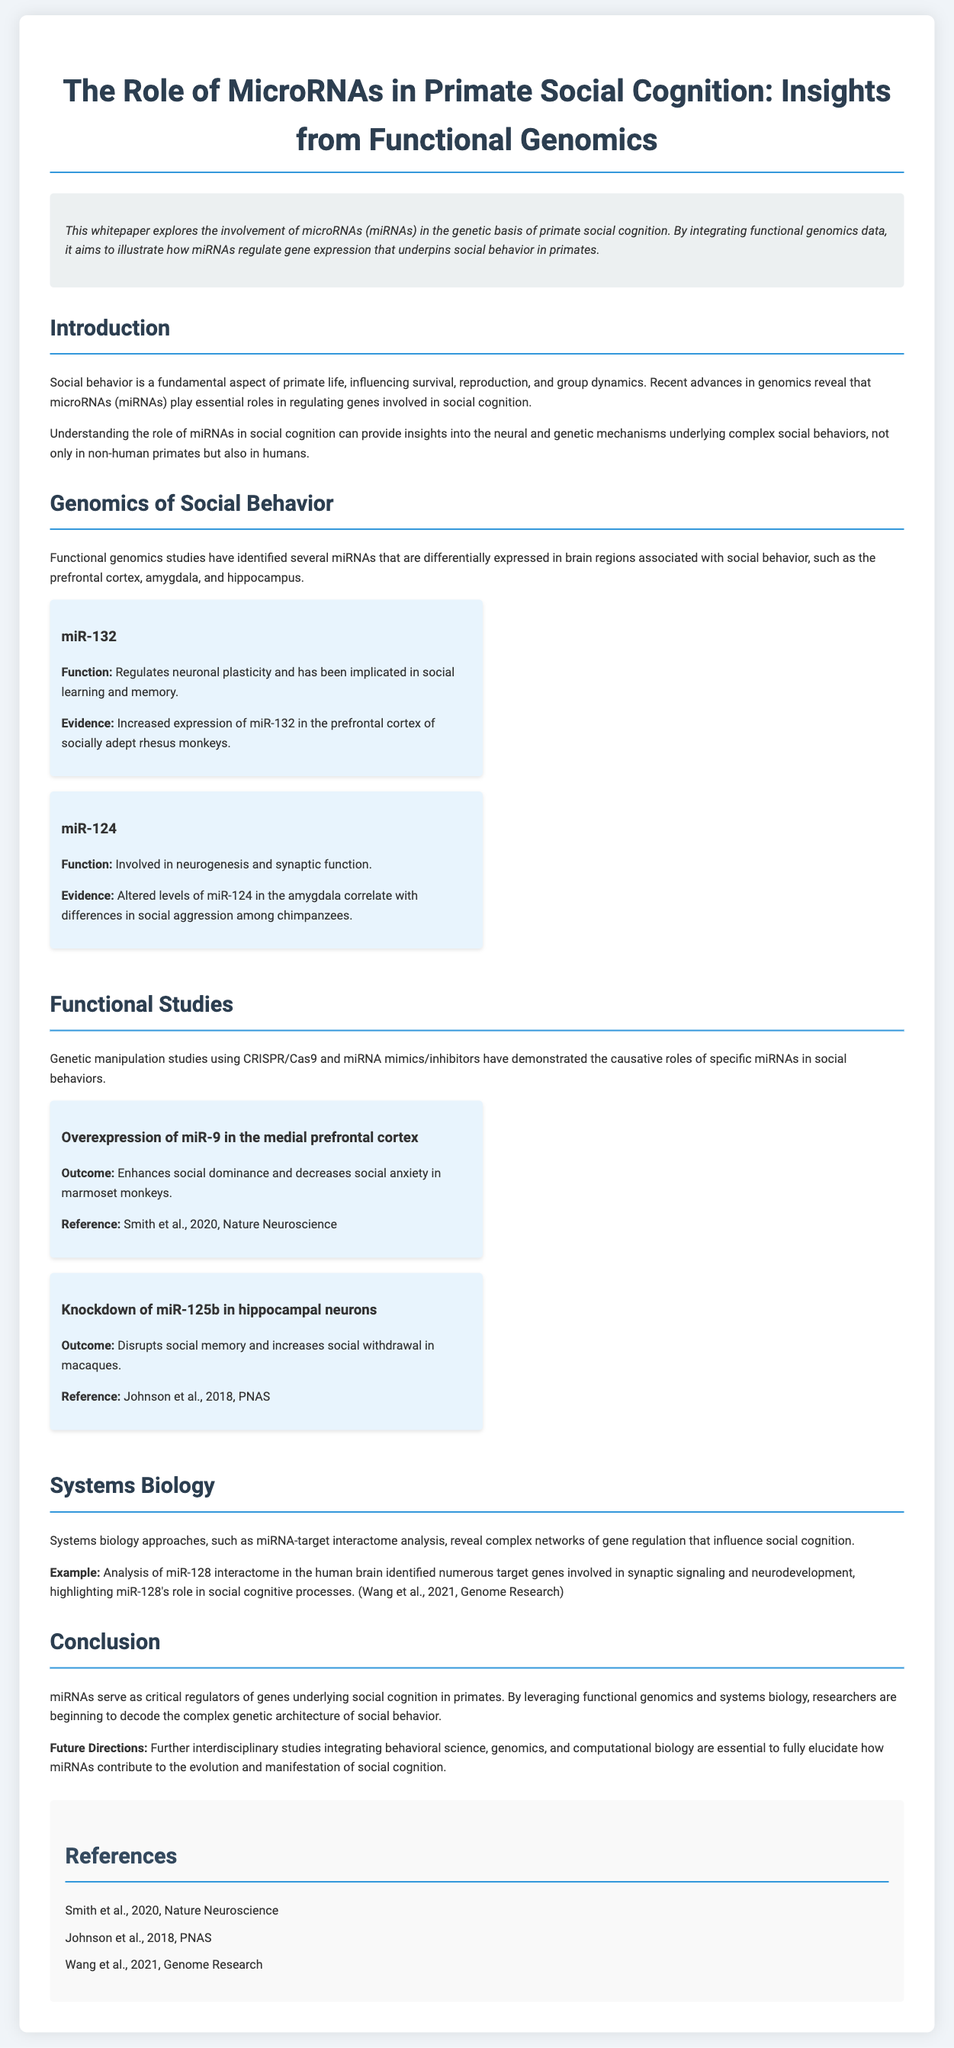What is the main focus of the whitepaper? The whitepaper explores the involvement of microRNAs in the genetic basis of primate social cognition.
Answer: microRNAs in primate social cognition Which microRNA is associated with social learning and memory? The document states that miR-132 regulates neuronal plasticity and is implicated in social learning and memory.
Answer: miR-132 What effect does overexpression of miR-9 have in marmoset monkeys? It enhances social dominance and decreases social anxiety in marmoset monkeys.
Answer: Enhances social dominance and decreases social anxiety What is the publication year of the study by Johnson et al.? The reference indicates that Johnson et al. published their study in 2018.
Answer: 2018 Which brain regions are mentioned in relation to miRNAs and social behavior? The prefrontal cortex, amygdala, and hippocampus are identified as brain regions associated with social behavior.
Answer: Prefrontal cortex, amygdala, hippocampus What does the systems biology approach help reveal in the document? It reveals complex networks of gene regulation that influence social cognition.
Answer: Complex networks of gene regulation What are the future directions mentioned for this research? The document suggests that further interdisciplinary studies are essential to fully elucidate how miRNAs contribute to social cognition.
Answer: Further interdisciplinary studies What is the title of the case study by Smith et al.? The case study conducted by Smith et al. focused on the overexpression of miR-9 in the medial prefrontal cortex.
Answer: Overexpression of miR-9 in the medial prefrontal cortex 